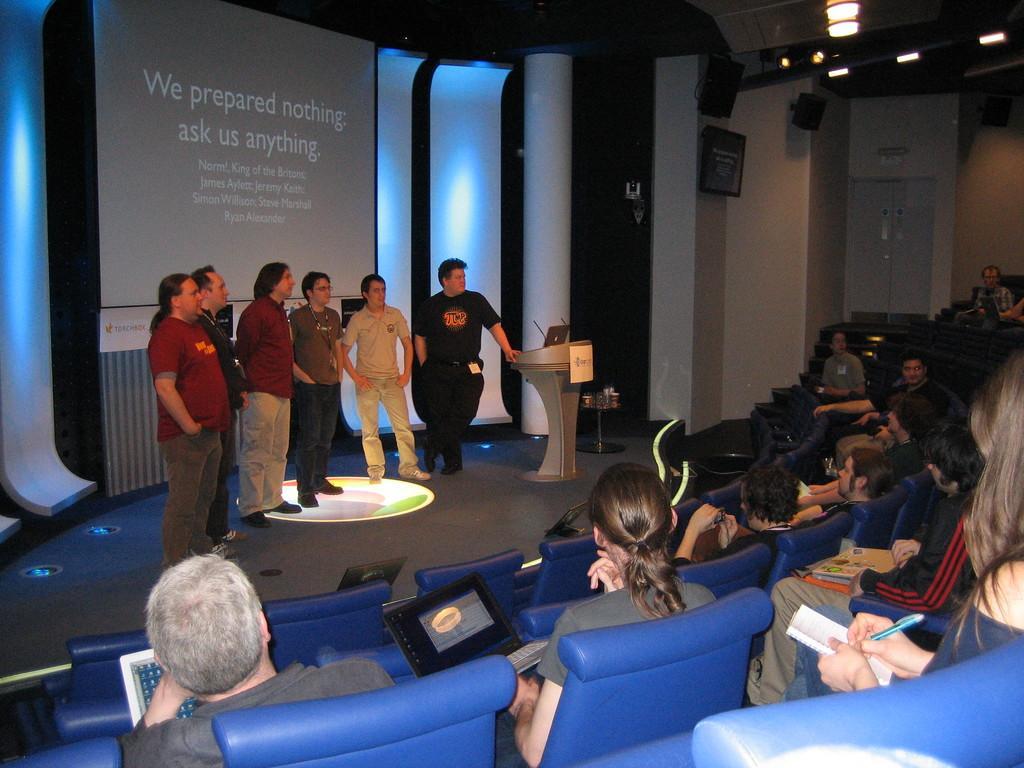Describe this image in one or two sentences. This picture is clicked in the conference hall. At the bottom, we see the people are sitting on the chairs. Most of them are holding the laptops, books and pens in their hands. In the middle, we see six men are standing. Beside them, we see a podium on which a laptop and the microphones are placed. Behind them, we see a projector screen which is displaying some text. Behind that, we see the white pillars. In the background, we see a white wall, white door and a photo frame is placed on the wall. At the top, we see the ceiling of the hall. 